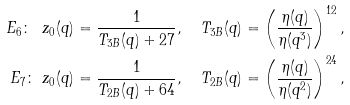Convert formula to latex. <formula><loc_0><loc_0><loc_500><loc_500>E _ { 6 } \colon \ z _ { 0 } ( q ) & = \frac { 1 } { T _ { 3 B } ( q ) + 2 7 } , \quad T _ { 3 B } ( q ) = \left ( \frac { \eta ( q ) } { \eta ( q ^ { 3 } ) } \right ) ^ { 1 2 } , \\ E _ { 7 } \colon \ z _ { 0 } ( q ) & = \frac { 1 } { T _ { 2 B } ( q ) + 6 4 } , \quad T _ { 2 B } ( q ) = \left ( \frac { \eta ( q ) } { \eta ( q ^ { 2 } ) } \right ) ^ { 2 4 } ,</formula> 